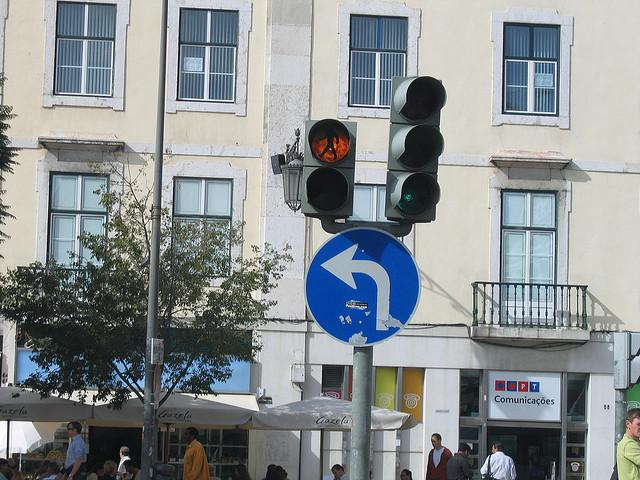What is the sign telling drivers? Please explain your reasoning. left only. The sign has a bent left arrow on it. 